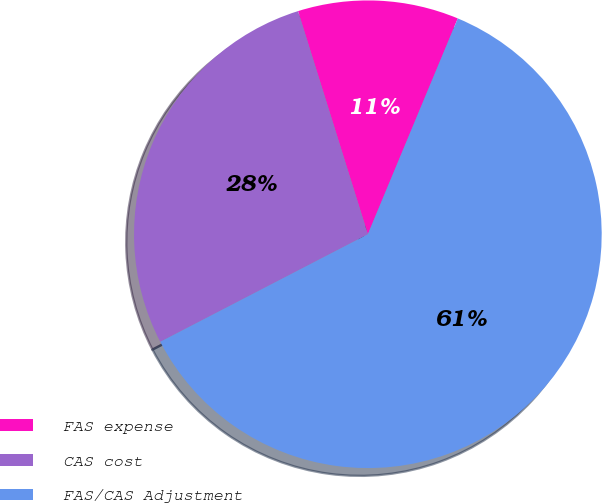<chart> <loc_0><loc_0><loc_500><loc_500><pie_chart><fcel>FAS expense<fcel>CAS cost<fcel>FAS/CAS Adjustment<nl><fcel>11.11%<fcel>27.78%<fcel>61.11%<nl></chart> 